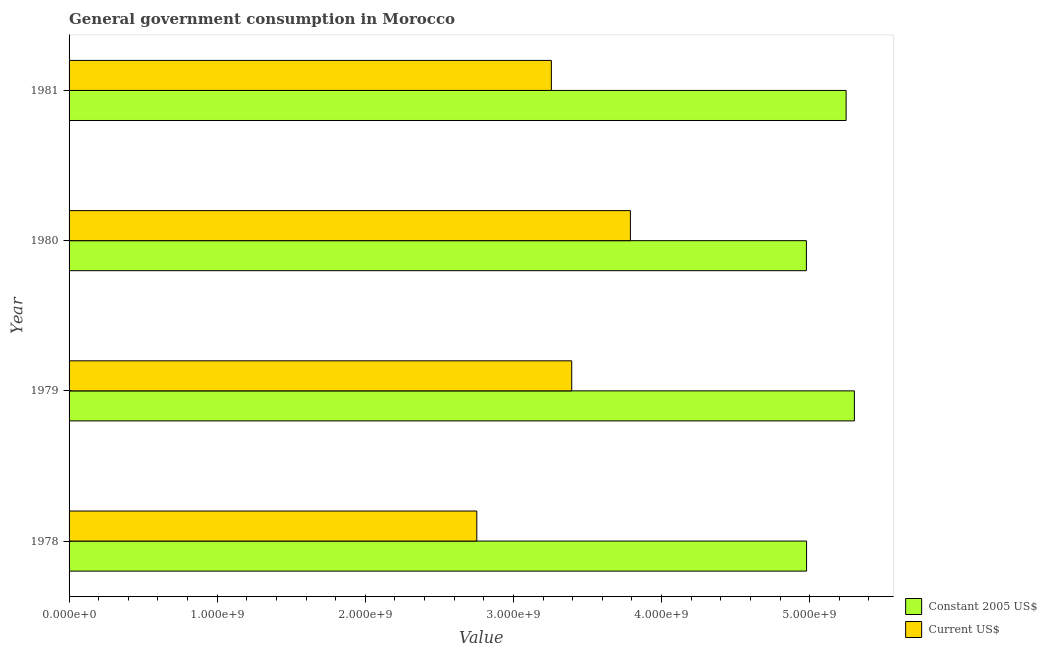Are the number of bars per tick equal to the number of legend labels?
Provide a short and direct response. Yes. Are the number of bars on each tick of the Y-axis equal?
Provide a succinct answer. Yes. What is the label of the 4th group of bars from the top?
Your response must be concise. 1978. In how many cases, is the number of bars for a given year not equal to the number of legend labels?
Make the answer very short. 0. What is the value consumed in constant 2005 us$ in 1980?
Offer a very short reply. 4.98e+09. Across all years, what is the maximum value consumed in current us$?
Ensure brevity in your answer.  3.79e+09. Across all years, what is the minimum value consumed in constant 2005 us$?
Your answer should be very brief. 4.98e+09. In which year was the value consumed in constant 2005 us$ minimum?
Provide a short and direct response. 1980. What is the total value consumed in constant 2005 us$ in the graph?
Your response must be concise. 2.05e+1. What is the difference between the value consumed in current us$ in 1978 and that in 1981?
Your response must be concise. -5.03e+08. What is the difference between the value consumed in constant 2005 us$ in 1979 and the value consumed in current us$ in 1980?
Give a very brief answer. 1.51e+09. What is the average value consumed in current us$ per year?
Your response must be concise. 3.30e+09. In the year 1981, what is the difference between the value consumed in current us$ and value consumed in constant 2005 us$?
Offer a terse response. -1.99e+09. In how many years, is the value consumed in current us$ greater than 4800000000 ?
Your answer should be very brief. 0. What is the ratio of the value consumed in current us$ in 1978 to that in 1980?
Offer a very short reply. 0.73. Is the difference between the value consumed in constant 2005 us$ in 1979 and 1981 greater than the difference between the value consumed in current us$ in 1979 and 1981?
Provide a short and direct response. No. What is the difference between the highest and the second highest value consumed in current us$?
Your response must be concise. 3.96e+08. What is the difference between the highest and the lowest value consumed in constant 2005 us$?
Provide a short and direct response. 3.24e+08. In how many years, is the value consumed in constant 2005 us$ greater than the average value consumed in constant 2005 us$ taken over all years?
Give a very brief answer. 2. Is the sum of the value consumed in current us$ in 1978 and 1981 greater than the maximum value consumed in constant 2005 us$ across all years?
Offer a terse response. Yes. What does the 1st bar from the top in 1980 represents?
Provide a succinct answer. Current US$. What does the 2nd bar from the bottom in 1978 represents?
Make the answer very short. Current US$. How many bars are there?
Provide a succinct answer. 8. Are all the bars in the graph horizontal?
Your response must be concise. Yes. What is the title of the graph?
Your answer should be compact. General government consumption in Morocco. Does "Personal remittances" appear as one of the legend labels in the graph?
Make the answer very short. No. What is the label or title of the X-axis?
Your answer should be compact. Value. What is the Value of Constant 2005 US$ in 1978?
Your answer should be compact. 4.98e+09. What is the Value in Current US$ in 1978?
Give a very brief answer. 2.75e+09. What is the Value in Constant 2005 US$ in 1979?
Your answer should be compact. 5.30e+09. What is the Value of Current US$ in 1979?
Provide a succinct answer. 3.39e+09. What is the Value in Constant 2005 US$ in 1980?
Offer a terse response. 4.98e+09. What is the Value of Current US$ in 1980?
Your answer should be compact. 3.79e+09. What is the Value in Constant 2005 US$ in 1981?
Keep it short and to the point. 5.25e+09. What is the Value of Current US$ in 1981?
Offer a very short reply. 3.26e+09. Across all years, what is the maximum Value in Constant 2005 US$?
Your answer should be compact. 5.30e+09. Across all years, what is the maximum Value of Current US$?
Provide a short and direct response. 3.79e+09. Across all years, what is the minimum Value of Constant 2005 US$?
Keep it short and to the point. 4.98e+09. Across all years, what is the minimum Value of Current US$?
Provide a short and direct response. 2.75e+09. What is the total Value of Constant 2005 US$ in the graph?
Provide a short and direct response. 2.05e+1. What is the total Value of Current US$ in the graph?
Provide a short and direct response. 1.32e+1. What is the difference between the Value of Constant 2005 US$ in 1978 and that in 1979?
Offer a terse response. -3.23e+08. What is the difference between the Value of Current US$ in 1978 and that in 1979?
Keep it short and to the point. -6.41e+08. What is the difference between the Value in Constant 2005 US$ in 1978 and that in 1980?
Ensure brevity in your answer.  1.28e+06. What is the difference between the Value of Current US$ in 1978 and that in 1980?
Provide a succinct answer. -1.04e+09. What is the difference between the Value in Constant 2005 US$ in 1978 and that in 1981?
Your answer should be very brief. -2.67e+08. What is the difference between the Value in Current US$ in 1978 and that in 1981?
Provide a succinct answer. -5.03e+08. What is the difference between the Value of Constant 2005 US$ in 1979 and that in 1980?
Offer a very short reply. 3.24e+08. What is the difference between the Value of Current US$ in 1979 and that in 1980?
Offer a terse response. -3.96e+08. What is the difference between the Value of Constant 2005 US$ in 1979 and that in 1981?
Your answer should be very brief. 5.56e+07. What is the difference between the Value of Current US$ in 1979 and that in 1981?
Your answer should be very brief. 1.37e+08. What is the difference between the Value in Constant 2005 US$ in 1980 and that in 1981?
Offer a terse response. -2.68e+08. What is the difference between the Value in Current US$ in 1980 and that in 1981?
Give a very brief answer. 5.34e+08. What is the difference between the Value of Constant 2005 US$ in 1978 and the Value of Current US$ in 1979?
Provide a short and direct response. 1.59e+09. What is the difference between the Value of Constant 2005 US$ in 1978 and the Value of Current US$ in 1980?
Provide a succinct answer. 1.19e+09. What is the difference between the Value in Constant 2005 US$ in 1978 and the Value in Current US$ in 1981?
Give a very brief answer. 1.72e+09. What is the difference between the Value in Constant 2005 US$ in 1979 and the Value in Current US$ in 1980?
Make the answer very short. 1.51e+09. What is the difference between the Value in Constant 2005 US$ in 1979 and the Value in Current US$ in 1981?
Keep it short and to the point. 2.05e+09. What is the difference between the Value in Constant 2005 US$ in 1980 and the Value in Current US$ in 1981?
Provide a succinct answer. 1.72e+09. What is the average Value of Constant 2005 US$ per year?
Ensure brevity in your answer.  5.13e+09. What is the average Value of Current US$ per year?
Ensure brevity in your answer.  3.30e+09. In the year 1978, what is the difference between the Value of Constant 2005 US$ and Value of Current US$?
Ensure brevity in your answer.  2.23e+09. In the year 1979, what is the difference between the Value in Constant 2005 US$ and Value in Current US$?
Give a very brief answer. 1.91e+09. In the year 1980, what is the difference between the Value of Constant 2005 US$ and Value of Current US$?
Offer a very short reply. 1.19e+09. In the year 1981, what is the difference between the Value of Constant 2005 US$ and Value of Current US$?
Your answer should be very brief. 1.99e+09. What is the ratio of the Value of Constant 2005 US$ in 1978 to that in 1979?
Give a very brief answer. 0.94. What is the ratio of the Value in Current US$ in 1978 to that in 1979?
Ensure brevity in your answer.  0.81. What is the ratio of the Value of Constant 2005 US$ in 1978 to that in 1980?
Offer a very short reply. 1. What is the ratio of the Value in Current US$ in 1978 to that in 1980?
Your response must be concise. 0.73. What is the ratio of the Value of Constant 2005 US$ in 1978 to that in 1981?
Your answer should be very brief. 0.95. What is the ratio of the Value of Current US$ in 1978 to that in 1981?
Ensure brevity in your answer.  0.85. What is the ratio of the Value of Constant 2005 US$ in 1979 to that in 1980?
Keep it short and to the point. 1.07. What is the ratio of the Value in Current US$ in 1979 to that in 1980?
Keep it short and to the point. 0.9. What is the ratio of the Value in Constant 2005 US$ in 1979 to that in 1981?
Keep it short and to the point. 1.01. What is the ratio of the Value of Current US$ in 1979 to that in 1981?
Your response must be concise. 1.04. What is the ratio of the Value of Constant 2005 US$ in 1980 to that in 1981?
Offer a terse response. 0.95. What is the ratio of the Value in Current US$ in 1980 to that in 1981?
Keep it short and to the point. 1.16. What is the difference between the highest and the second highest Value in Constant 2005 US$?
Keep it short and to the point. 5.56e+07. What is the difference between the highest and the second highest Value in Current US$?
Your answer should be compact. 3.96e+08. What is the difference between the highest and the lowest Value of Constant 2005 US$?
Ensure brevity in your answer.  3.24e+08. What is the difference between the highest and the lowest Value in Current US$?
Offer a very short reply. 1.04e+09. 